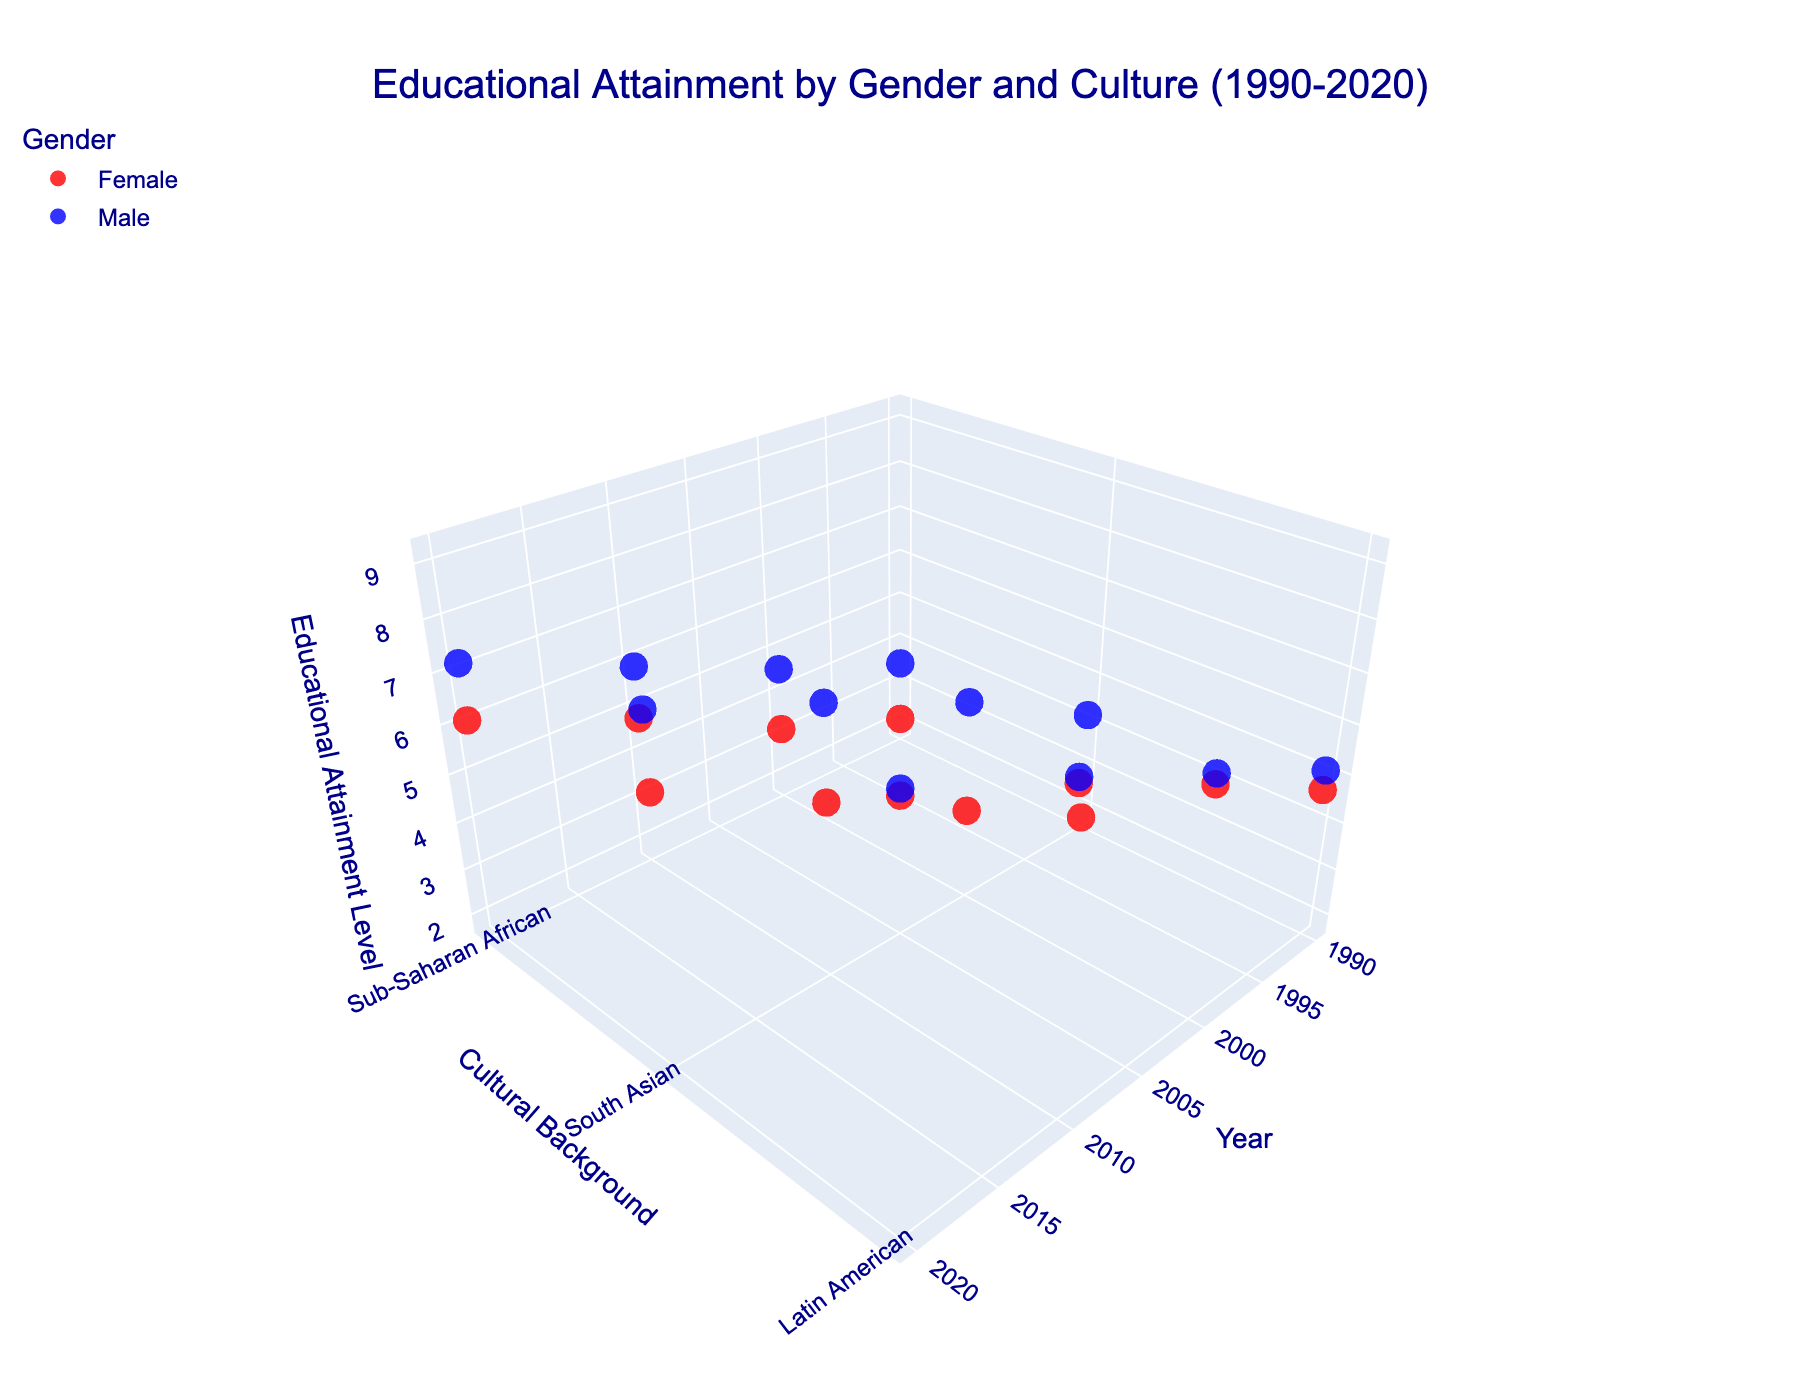what is the educational attainment level for South Asian females in 2020? Locate the data point for females (red marker) on the South Asian (y-axis) cultural background and corresponding point in the 2020 year. The z-axis value indicates the educational attainment level.
Answer: 6.9 What is the change in educational attainment level for Sub-Saharan African males from 1990 to 2020? Locate the points for Sub-Saharan African males (blue marker) in 1990 and 2020. Subtract the 1990 value (3.5) from the 2020 value (7.2).
Answer: 7.2 - 3.5 = 3.7 Which gender among South Asians had a higher increase in educational attainment from 1990 to 2020? Calculate the difference in educational attainment for both genders. For females: 6.9 - 1.8 = 5.1; for males: 8.3 - 4.2 = 4.1. Compare the two increases.
Answer: Females had a higher increase (5.1) In which decade did Latin American females see the sharpest rise in educational attainment? Compare the rise in educational attainment levels between each decade (1990-2000, 2000-2010, 2010-2020). Identify which period has the highest rise in value. 2000 (6.3) - 1990 (4.7) = 1.6; 2010 (7.8) - 2000 (6.3) = 1.5; 2020 (9.1) - 2010 (7.8) = 1.3.
Answer: 1990-2000 What is the educational attainment level gender gap in Latin American culture in 2020? Subtract the female educational attainment level (9.1) from the male educational attainment level (9.2) for Latin Americans in 2020.
Answer: 9.2 - 9.1 = 0.1 How have educational attainment levels trended for South Asian females from 1990 to 2020? Observing the red markers over the years for South Asian females, note the trend of the z-axis values: 1990 (1.8), 2000 (3.5), 2010 (5.2), 2020 (6.9). All values consistently increase over time.
Answer: Increasing trend 